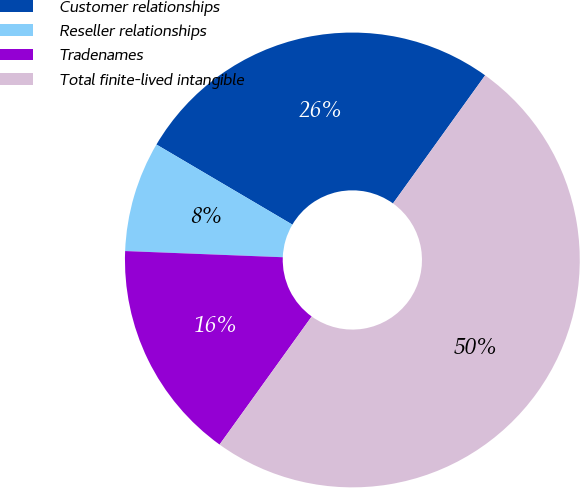<chart> <loc_0><loc_0><loc_500><loc_500><pie_chart><fcel>Customer relationships<fcel>Reseller relationships<fcel>Tradenames<fcel>Total finite-lived intangible<nl><fcel>26.45%<fcel>7.85%<fcel>15.7%<fcel>50.0%<nl></chart> 